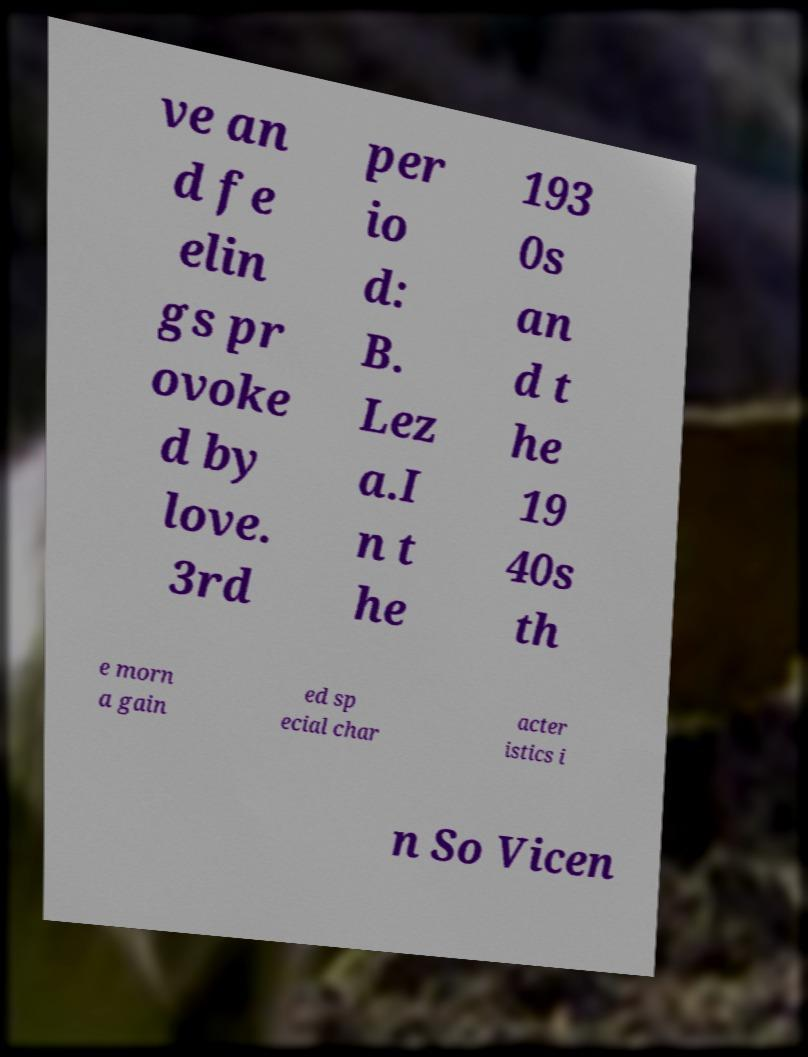Please identify and transcribe the text found in this image. ve an d fe elin gs pr ovoke d by love. 3rd per io d: B. Lez a.I n t he 193 0s an d t he 19 40s th e morn a gain ed sp ecial char acter istics i n So Vicen 